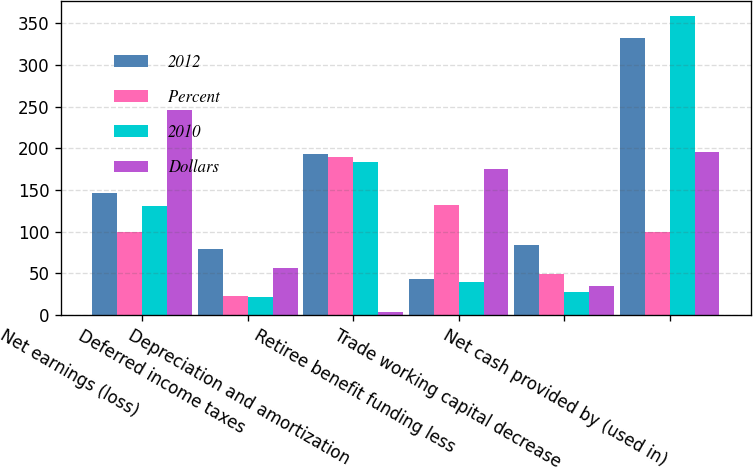Convert chart to OTSL. <chart><loc_0><loc_0><loc_500><loc_500><stacked_bar_chart><ecel><fcel>Net earnings (loss)<fcel>Deferred income taxes<fcel>Depreciation and amortization<fcel>Retiree benefit funding less<fcel>Trade working capital decrease<fcel>Net cash provided by (used in)<nl><fcel>2012<fcel>146<fcel>79<fcel>193<fcel>43<fcel>84<fcel>332<nl><fcel>Percent<fcel>100<fcel>23<fcel>190<fcel>132<fcel>49<fcel>100<nl><fcel>2010<fcel>131<fcel>21<fcel>183<fcel>39<fcel>27<fcel>359<nl><fcel>Dollars<fcel>246<fcel>56<fcel>3<fcel>175<fcel>35<fcel>196<nl></chart> 